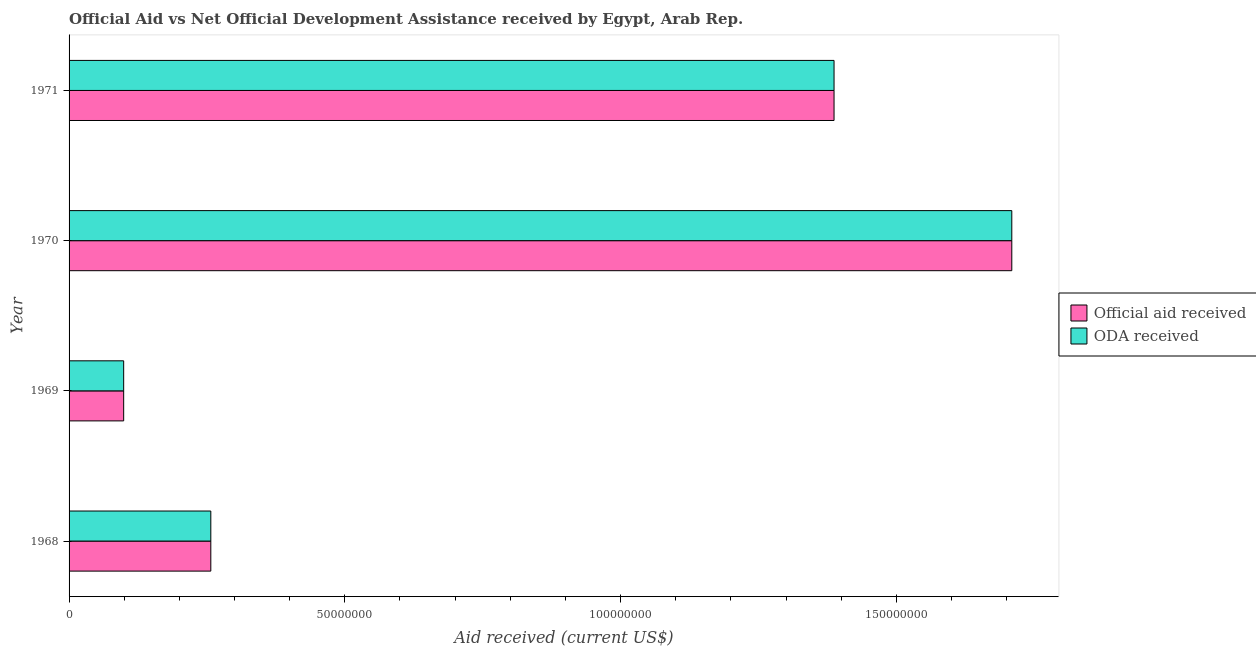How many different coloured bars are there?
Ensure brevity in your answer.  2. How many bars are there on the 2nd tick from the top?
Provide a short and direct response. 2. How many bars are there on the 1st tick from the bottom?
Keep it short and to the point. 2. What is the label of the 2nd group of bars from the top?
Offer a very short reply. 1970. What is the official aid received in 1971?
Provide a succinct answer. 1.39e+08. Across all years, what is the maximum official aid received?
Make the answer very short. 1.71e+08. Across all years, what is the minimum official aid received?
Provide a short and direct response. 9.90e+06. In which year was the official aid received minimum?
Provide a short and direct response. 1969. What is the total official aid received in the graph?
Provide a short and direct response. 3.45e+08. What is the difference between the oda received in 1969 and that in 1971?
Make the answer very short. -1.29e+08. What is the difference between the oda received in 1971 and the official aid received in 1970?
Ensure brevity in your answer.  -3.22e+07. What is the average official aid received per year?
Provide a succinct answer. 8.63e+07. What is the ratio of the oda received in 1969 to that in 1970?
Offer a terse response. 0.06. What is the difference between the highest and the second highest oda received?
Make the answer very short. 3.22e+07. What is the difference between the highest and the lowest official aid received?
Offer a very short reply. 1.61e+08. Is the sum of the oda received in 1969 and 1971 greater than the maximum official aid received across all years?
Make the answer very short. No. What does the 1st bar from the top in 1968 represents?
Keep it short and to the point. ODA received. What does the 1st bar from the bottom in 1970 represents?
Ensure brevity in your answer.  Official aid received. How many bars are there?
Your answer should be very brief. 8. What is the difference between two consecutive major ticks on the X-axis?
Make the answer very short. 5.00e+07. Are the values on the major ticks of X-axis written in scientific E-notation?
Your response must be concise. No. What is the title of the graph?
Provide a short and direct response. Official Aid vs Net Official Development Assistance received by Egypt, Arab Rep. . Does "Highest 20% of population" appear as one of the legend labels in the graph?
Your response must be concise. No. What is the label or title of the X-axis?
Provide a short and direct response. Aid received (current US$). What is the Aid received (current US$) of Official aid received in 1968?
Provide a succinct answer. 2.57e+07. What is the Aid received (current US$) of ODA received in 1968?
Give a very brief answer. 2.57e+07. What is the Aid received (current US$) of Official aid received in 1969?
Your response must be concise. 9.90e+06. What is the Aid received (current US$) of ODA received in 1969?
Give a very brief answer. 9.90e+06. What is the Aid received (current US$) of Official aid received in 1970?
Ensure brevity in your answer.  1.71e+08. What is the Aid received (current US$) of ODA received in 1970?
Your response must be concise. 1.71e+08. What is the Aid received (current US$) of Official aid received in 1971?
Provide a succinct answer. 1.39e+08. What is the Aid received (current US$) of ODA received in 1971?
Provide a succinct answer. 1.39e+08. Across all years, what is the maximum Aid received (current US$) in Official aid received?
Give a very brief answer. 1.71e+08. Across all years, what is the maximum Aid received (current US$) of ODA received?
Make the answer very short. 1.71e+08. Across all years, what is the minimum Aid received (current US$) of Official aid received?
Your response must be concise. 9.90e+06. Across all years, what is the minimum Aid received (current US$) of ODA received?
Your answer should be compact. 9.90e+06. What is the total Aid received (current US$) in Official aid received in the graph?
Make the answer very short. 3.45e+08. What is the total Aid received (current US$) of ODA received in the graph?
Make the answer very short. 3.45e+08. What is the difference between the Aid received (current US$) of Official aid received in 1968 and that in 1969?
Make the answer very short. 1.58e+07. What is the difference between the Aid received (current US$) in ODA received in 1968 and that in 1969?
Your answer should be compact. 1.58e+07. What is the difference between the Aid received (current US$) in Official aid received in 1968 and that in 1970?
Make the answer very short. -1.45e+08. What is the difference between the Aid received (current US$) in ODA received in 1968 and that in 1970?
Give a very brief answer. -1.45e+08. What is the difference between the Aid received (current US$) in Official aid received in 1968 and that in 1971?
Your response must be concise. -1.13e+08. What is the difference between the Aid received (current US$) in ODA received in 1968 and that in 1971?
Ensure brevity in your answer.  -1.13e+08. What is the difference between the Aid received (current US$) of Official aid received in 1969 and that in 1970?
Offer a terse response. -1.61e+08. What is the difference between the Aid received (current US$) of ODA received in 1969 and that in 1970?
Offer a terse response. -1.61e+08. What is the difference between the Aid received (current US$) of Official aid received in 1969 and that in 1971?
Offer a terse response. -1.29e+08. What is the difference between the Aid received (current US$) in ODA received in 1969 and that in 1971?
Give a very brief answer. -1.29e+08. What is the difference between the Aid received (current US$) in Official aid received in 1970 and that in 1971?
Provide a succinct answer. 3.22e+07. What is the difference between the Aid received (current US$) of ODA received in 1970 and that in 1971?
Make the answer very short. 3.22e+07. What is the difference between the Aid received (current US$) in Official aid received in 1968 and the Aid received (current US$) in ODA received in 1969?
Your response must be concise. 1.58e+07. What is the difference between the Aid received (current US$) in Official aid received in 1968 and the Aid received (current US$) in ODA received in 1970?
Make the answer very short. -1.45e+08. What is the difference between the Aid received (current US$) of Official aid received in 1968 and the Aid received (current US$) of ODA received in 1971?
Your answer should be very brief. -1.13e+08. What is the difference between the Aid received (current US$) of Official aid received in 1969 and the Aid received (current US$) of ODA received in 1970?
Your response must be concise. -1.61e+08. What is the difference between the Aid received (current US$) in Official aid received in 1969 and the Aid received (current US$) in ODA received in 1971?
Your answer should be very brief. -1.29e+08. What is the difference between the Aid received (current US$) in Official aid received in 1970 and the Aid received (current US$) in ODA received in 1971?
Give a very brief answer. 3.22e+07. What is the average Aid received (current US$) in Official aid received per year?
Your response must be concise. 8.63e+07. What is the average Aid received (current US$) in ODA received per year?
Keep it short and to the point. 8.63e+07. In the year 1968, what is the difference between the Aid received (current US$) in Official aid received and Aid received (current US$) in ODA received?
Ensure brevity in your answer.  0. In the year 1971, what is the difference between the Aid received (current US$) in Official aid received and Aid received (current US$) in ODA received?
Your answer should be compact. 0. What is the ratio of the Aid received (current US$) of Official aid received in 1968 to that in 1969?
Your response must be concise. 2.6. What is the ratio of the Aid received (current US$) of ODA received in 1968 to that in 1969?
Make the answer very short. 2.6. What is the ratio of the Aid received (current US$) of Official aid received in 1968 to that in 1970?
Your answer should be very brief. 0.15. What is the ratio of the Aid received (current US$) of ODA received in 1968 to that in 1970?
Offer a very short reply. 0.15. What is the ratio of the Aid received (current US$) of Official aid received in 1968 to that in 1971?
Your answer should be compact. 0.19. What is the ratio of the Aid received (current US$) of ODA received in 1968 to that in 1971?
Offer a terse response. 0.19. What is the ratio of the Aid received (current US$) in Official aid received in 1969 to that in 1970?
Your answer should be compact. 0.06. What is the ratio of the Aid received (current US$) of ODA received in 1969 to that in 1970?
Offer a very short reply. 0.06. What is the ratio of the Aid received (current US$) in Official aid received in 1969 to that in 1971?
Your answer should be compact. 0.07. What is the ratio of the Aid received (current US$) of ODA received in 1969 to that in 1971?
Give a very brief answer. 0.07. What is the ratio of the Aid received (current US$) of Official aid received in 1970 to that in 1971?
Your response must be concise. 1.23. What is the ratio of the Aid received (current US$) of ODA received in 1970 to that in 1971?
Your response must be concise. 1.23. What is the difference between the highest and the second highest Aid received (current US$) of Official aid received?
Your answer should be very brief. 3.22e+07. What is the difference between the highest and the second highest Aid received (current US$) in ODA received?
Your answer should be very brief. 3.22e+07. What is the difference between the highest and the lowest Aid received (current US$) of Official aid received?
Give a very brief answer. 1.61e+08. What is the difference between the highest and the lowest Aid received (current US$) of ODA received?
Your answer should be very brief. 1.61e+08. 